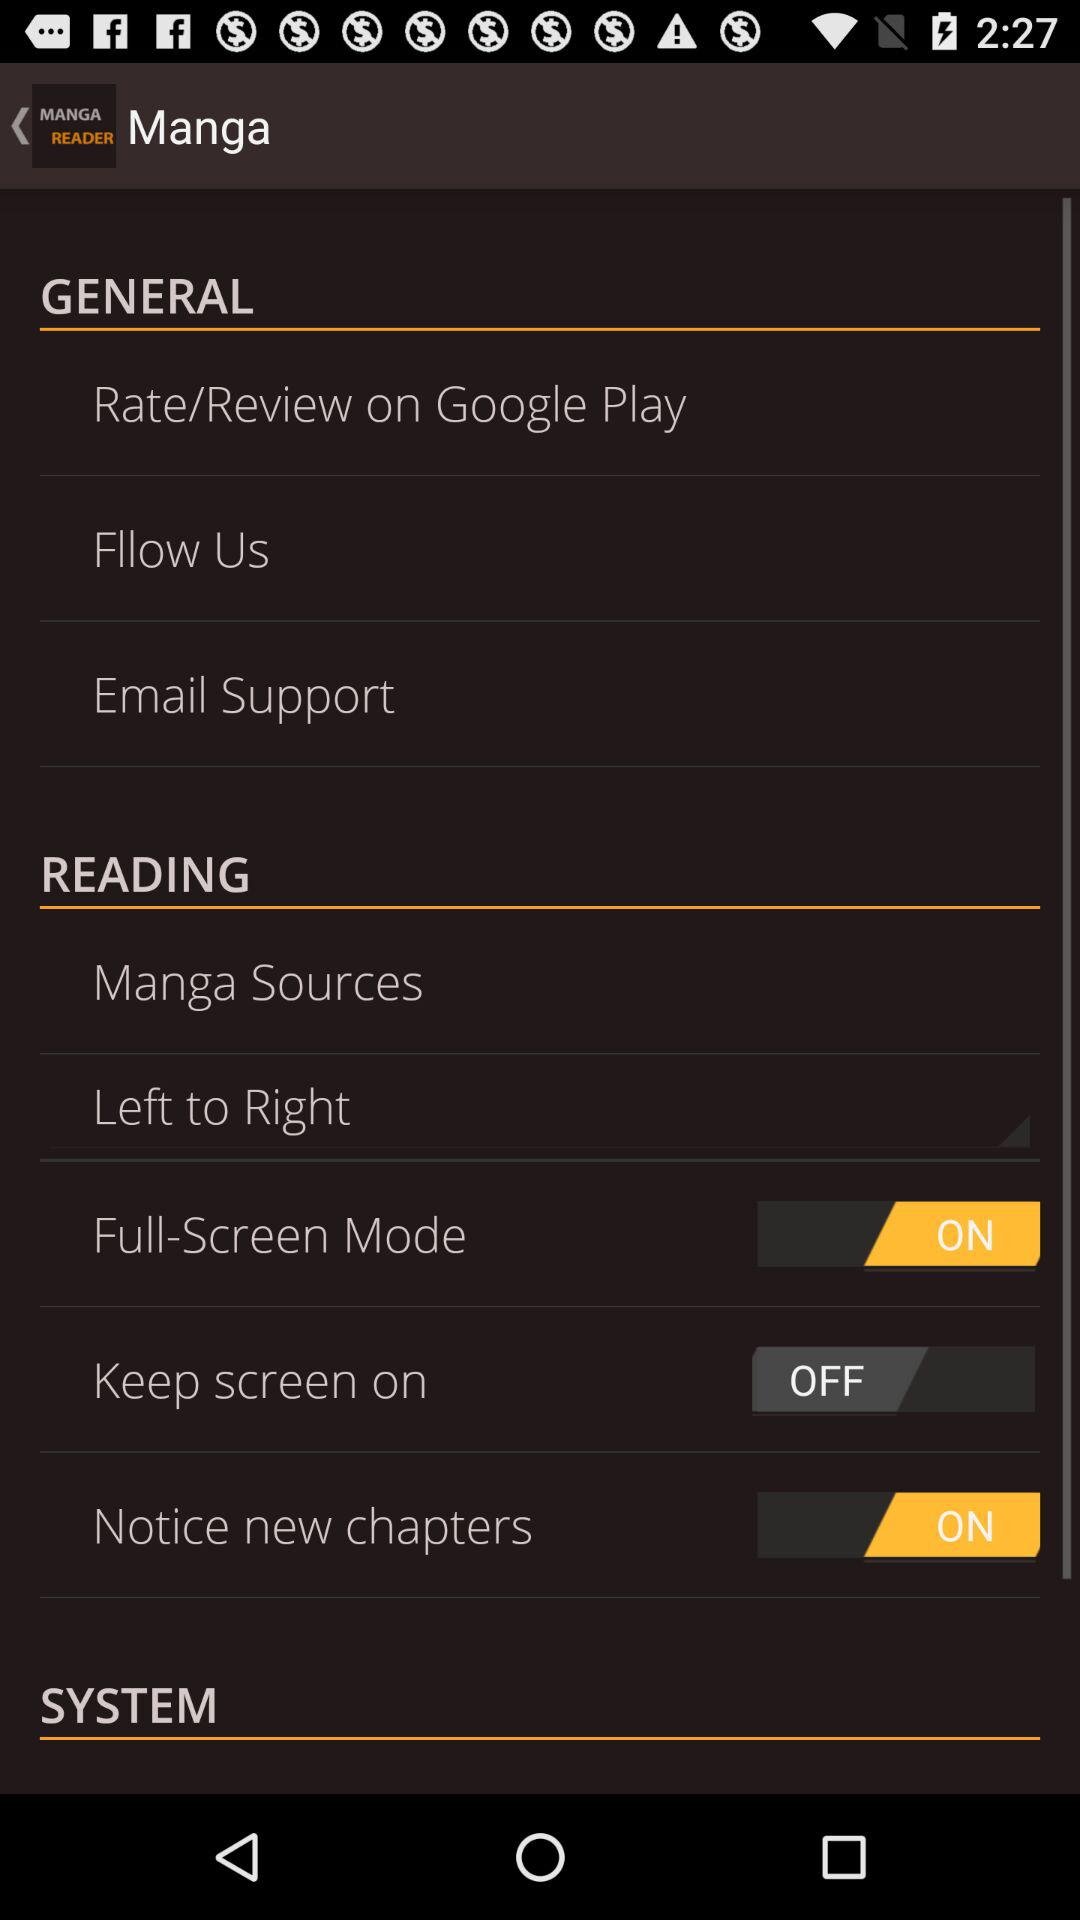What is the status of "Keep screen on"? "Keep screen on" is turned off. 